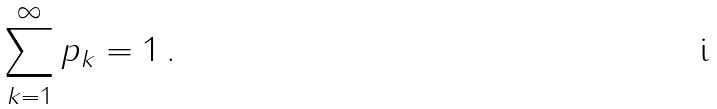Convert formula to latex. <formula><loc_0><loc_0><loc_500><loc_500>\sum _ { k = 1 } ^ { \infty } p _ { k } = 1 \, .</formula> 